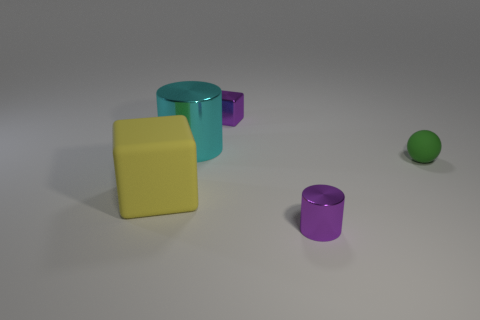What material is the cylinder that is the same color as the small shiny cube?
Provide a succinct answer. Metal. There is a green rubber object; what number of small green matte balls are right of it?
Provide a short and direct response. 0. What number of cylinders are the same material as the small green object?
Your answer should be compact. 0. There is a cube that is made of the same material as the cyan thing; what color is it?
Offer a terse response. Purple. What material is the tiny purple thing in front of the block that is behind the cube in front of the sphere?
Offer a terse response. Metal. Do the purple metal thing that is left of the purple cylinder and the tiny purple cylinder have the same size?
Your answer should be compact. Yes. How many tiny things are green balls or brown metallic cylinders?
Provide a short and direct response. 1. Is there a small cylinder that has the same color as the metallic block?
Your response must be concise. Yes. The yellow matte thing that is the same size as the cyan cylinder is what shape?
Provide a short and direct response. Cube. There is a small metallic thing that is behind the small purple metallic cylinder; does it have the same color as the rubber block?
Offer a terse response. No. 